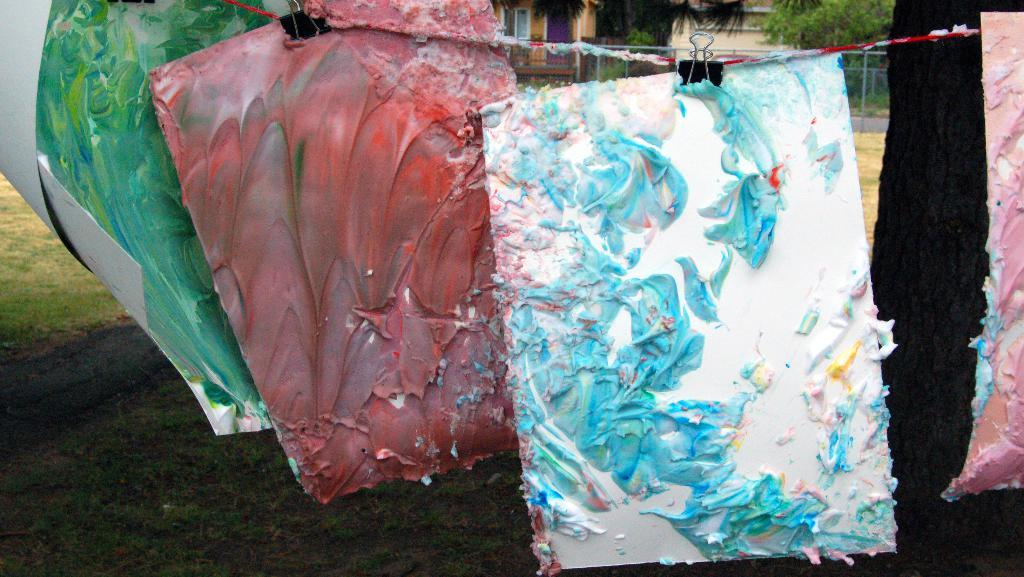What is depicted in the image? There are paintings in the image. How are the paintings displayed? The paintings are hung on a hanger. What can be seen in the background of the image? There are trees and houses in the background of the image. Is there a protest happening in the image? There is no indication of a protest in the image; it features paintings hung on a hanger with a background of trees and houses. 